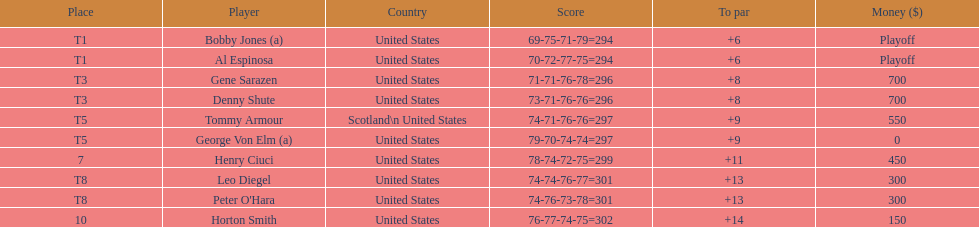What's the count of players who have been part of the scotland squad? 1. 